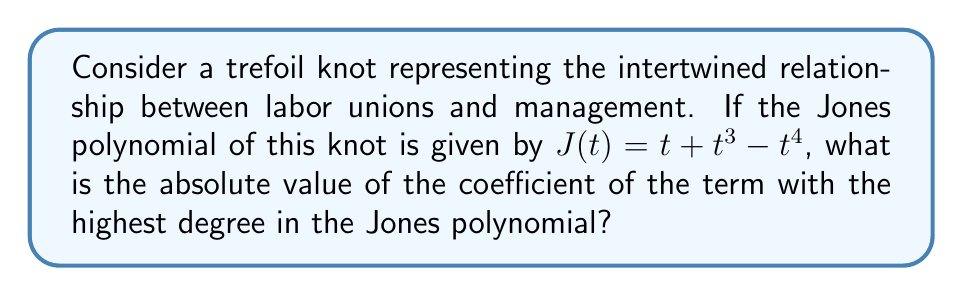Show me your answer to this math problem. To solve this problem, we need to follow these steps:

1. Identify the Jones polynomial:
   $J(t) = t + t^3 - t^4$

2. Determine the term with the highest degree:
   The highest degree term is $-t^4$

3. Identify the coefficient of this term:
   The coefficient is $-1$

4. Calculate the absolute value of this coefficient:
   $|-1| = 1$

This result can be interpreted in the context of union-management relations:
- The trefoil knot represents the complex, intertwined nature of the relationship.
- The Jones polynomial provides a mathematical description of this relationship.
- The coefficient of the highest degree term (in this case, 1) can be seen as a measure of the strength or significance of the most complex interactions between unions and management.
Answer: 1 